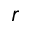Convert formula to latex. <formula><loc_0><loc_0><loc_500><loc_500>\boldsymbol r</formula> 